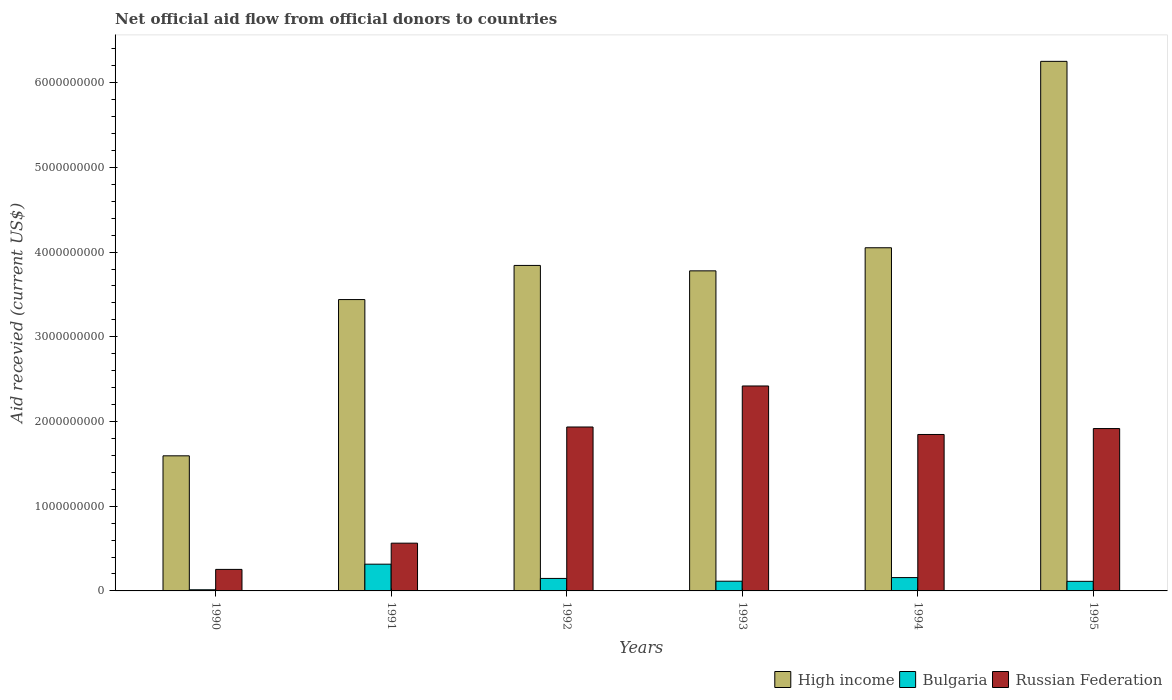How many different coloured bars are there?
Your answer should be very brief. 3. How many groups of bars are there?
Keep it short and to the point. 6. Are the number of bars per tick equal to the number of legend labels?
Make the answer very short. Yes. Are the number of bars on each tick of the X-axis equal?
Provide a short and direct response. Yes. What is the total aid received in Russian Federation in 1990?
Make the answer very short. 2.54e+08. Across all years, what is the maximum total aid received in Bulgaria?
Offer a terse response. 3.16e+08. Across all years, what is the minimum total aid received in Russian Federation?
Offer a terse response. 2.54e+08. In which year was the total aid received in High income minimum?
Keep it short and to the point. 1990. What is the total total aid received in High income in the graph?
Offer a terse response. 2.30e+1. What is the difference between the total aid received in Bulgaria in 1990 and that in 1993?
Keep it short and to the point. -1.01e+08. What is the difference between the total aid received in Bulgaria in 1993 and the total aid received in Russian Federation in 1990?
Provide a short and direct response. -1.39e+08. What is the average total aid received in Russian Federation per year?
Provide a succinct answer. 1.49e+09. In the year 1995, what is the difference between the total aid received in High income and total aid received in Bulgaria?
Give a very brief answer. 6.14e+09. In how many years, is the total aid received in High income greater than 1600000000 US$?
Make the answer very short. 5. What is the ratio of the total aid received in Bulgaria in 1992 to that in 1995?
Offer a very short reply. 1.3. What is the difference between the highest and the second highest total aid received in Bulgaria?
Your answer should be compact. 1.58e+08. What is the difference between the highest and the lowest total aid received in Russian Federation?
Provide a succinct answer. 2.17e+09. Is the sum of the total aid received in High income in 1990 and 1994 greater than the maximum total aid received in Russian Federation across all years?
Your answer should be compact. Yes. What does the 2nd bar from the right in 1995 represents?
Give a very brief answer. Bulgaria. Is it the case that in every year, the sum of the total aid received in High income and total aid received in Russian Federation is greater than the total aid received in Bulgaria?
Make the answer very short. Yes. Are all the bars in the graph horizontal?
Offer a very short reply. No. How many years are there in the graph?
Keep it short and to the point. 6. What is the difference between two consecutive major ticks on the Y-axis?
Your answer should be very brief. 1.00e+09. How many legend labels are there?
Keep it short and to the point. 3. How are the legend labels stacked?
Your answer should be compact. Horizontal. What is the title of the graph?
Provide a succinct answer. Net official aid flow from official donors to countries. What is the label or title of the Y-axis?
Provide a short and direct response. Aid recevied (current US$). What is the Aid recevied (current US$) in High income in 1990?
Your answer should be compact. 1.59e+09. What is the Aid recevied (current US$) in Bulgaria in 1990?
Provide a short and direct response. 1.36e+07. What is the Aid recevied (current US$) in Russian Federation in 1990?
Your answer should be compact. 2.54e+08. What is the Aid recevied (current US$) in High income in 1991?
Provide a succinct answer. 3.44e+09. What is the Aid recevied (current US$) of Bulgaria in 1991?
Your answer should be compact. 3.16e+08. What is the Aid recevied (current US$) in Russian Federation in 1991?
Keep it short and to the point. 5.64e+08. What is the Aid recevied (current US$) in High income in 1992?
Keep it short and to the point. 3.84e+09. What is the Aid recevied (current US$) in Bulgaria in 1992?
Ensure brevity in your answer.  1.48e+08. What is the Aid recevied (current US$) of Russian Federation in 1992?
Keep it short and to the point. 1.94e+09. What is the Aid recevied (current US$) of High income in 1993?
Provide a short and direct response. 3.78e+09. What is the Aid recevied (current US$) in Bulgaria in 1993?
Your response must be concise. 1.15e+08. What is the Aid recevied (current US$) in Russian Federation in 1993?
Offer a terse response. 2.42e+09. What is the Aid recevied (current US$) of High income in 1994?
Your answer should be compact. 4.05e+09. What is the Aid recevied (current US$) of Bulgaria in 1994?
Ensure brevity in your answer.  1.57e+08. What is the Aid recevied (current US$) in Russian Federation in 1994?
Your answer should be very brief. 1.85e+09. What is the Aid recevied (current US$) of High income in 1995?
Provide a succinct answer. 6.25e+09. What is the Aid recevied (current US$) in Bulgaria in 1995?
Make the answer very short. 1.13e+08. What is the Aid recevied (current US$) of Russian Federation in 1995?
Your response must be concise. 1.92e+09. Across all years, what is the maximum Aid recevied (current US$) of High income?
Ensure brevity in your answer.  6.25e+09. Across all years, what is the maximum Aid recevied (current US$) in Bulgaria?
Make the answer very short. 3.16e+08. Across all years, what is the maximum Aid recevied (current US$) of Russian Federation?
Provide a succinct answer. 2.42e+09. Across all years, what is the minimum Aid recevied (current US$) of High income?
Ensure brevity in your answer.  1.59e+09. Across all years, what is the minimum Aid recevied (current US$) of Bulgaria?
Make the answer very short. 1.36e+07. Across all years, what is the minimum Aid recevied (current US$) in Russian Federation?
Make the answer very short. 2.54e+08. What is the total Aid recevied (current US$) in High income in the graph?
Your response must be concise. 2.30e+1. What is the total Aid recevied (current US$) in Bulgaria in the graph?
Your response must be concise. 8.62e+08. What is the total Aid recevied (current US$) of Russian Federation in the graph?
Offer a very short reply. 8.94e+09. What is the difference between the Aid recevied (current US$) in High income in 1990 and that in 1991?
Your response must be concise. -1.84e+09. What is the difference between the Aid recevied (current US$) of Bulgaria in 1990 and that in 1991?
Ensure brevity in your answer.  -3.02e+08. What is the difference between the Aid recevied (current US$) in Russian Federation in 1990 and that in 1991?
Your answer should be compact. -3.10e+08. What is the difference between the Aid recevied (current US$) in High income in 1990 and that in 1992?
Ensure brevity in your answer.  -2.25e+09. What is the difference between the Aid recevied (current US$) of Bulgaria in 1990 and that in 1992?
Keep it short and to the point. -1.34e+08. What is the difference between the Aid recevied (current US$) of Russian Federation in 1990 and that in 1992?
Offer a terse response. -1.68e+09. What is the difference between the Aid recevied (current US$) of High income in 1990 and that in 1993?
Your answer should be compact. -2.18e+09. What is the difference between the Aid recevied (current US$) in Bulgaria in 1990 and that in 1993?
Make the answer very short. -1.01e+08. What is the difference between the Aid recevied (current US$) in Russian Federation in 1990 and that in 1993?
Offer a terse response. -2.17e+09. What is the difference between the Aid recevied (current US$) of High income in 1990 and that in 1994?
Offer a very short reply. -2.46e+09. What is the difference between the Aid recevied (current US$) of Bulgaria in 1990 and that in 1994?
Give a very brief answer. -1.44e+08. What is the difference between the Aid recevied (current US$) in Russian Federation in 1990 and that in 1994?
Offer a terse response. -1.59e+09. What is the difference between the Aid recevied (current US$) in High income in 1990 and that in 1995?
Keep it short and to the point. -4.66e+09. What is the difference between the Aid recevied (current US$) of Bulgaria in 1990 and that in 1995?
Your answer should be compact. -9.94e+07. What is the difference between the Aid recevied (current US$) in Russian Federation in 1990 and that in 1995?
Provide a short and direct response. -1.66e+09. What is the difference between the Aid recevied (current US$) in High income in 1991 and that in 1992?
Offer a very short reply. -4.03e+08. What is the difference between the Aid recevied (current US$) of Bulgaria in 1991 and that in 1992?
Ensure brevity in your answer.  1.68e+08. What is the difference between the Aid recevied (current US$) of Russian Federation in 1991 and that in 1992?
Your response must be concise. -1.37e+09. What is the difference between the Aid recevied (current US$) in High income in 1991 and that in 1993?
Give a very brief answer. -3.39e+08. What is the difference between the Aid recevied (current US$) in Bulgaria in 1991 and that in 1993?
Your answer should be very brief. 2.01e+08. What is the difference between the Aid recevied (current US$) of Russian Federation in 1991 and that in 1993?
Make the answer very short. -1.86e+09. What is the difference between the Aid recevied (current US$) of High income in 1991 and that in 1994?
Provide a succinct answer. -6.12e+08. What is the difference between the Aid recevied (current US$) in Bulgaria in 1991 and that in 1994?
Keep it short and to the point. 1.58e+08. What is the difference between the Aid recevied (current US$) in Russian Federation in 1991 and that in 1994?
Your answer should be very brief. -1.28e+09. What is the difference between the Aid recevied (current US$) in High income in 1991 and that in 1995?
Ensure brevity in your answer.  -2.81e+09. What is the difference between the Aid recevied (current US$) of Bulgaria in 1991 and that in 1995?
Keep it short and to the point. 2.03e+08. What is the difference between the Aid recevied (current US$) in Russian Federation in 1991 and that in 1995?
Offer a terse response. -1.35e+09. What is the difference between the Aid recevied (current US$) of High income in 1992 and that in 1993?
Your answer should be compact. 6.39e+07. What is the difference between the Aid recevied (current US$) in Bulgaria in 1992 and that in 1993?
Give a very brief answer. 3.29e+07. What is the difference between the Aid recevied (current US$) of Russian Federation in 1992 and that in 1993?
Offer a terse response. -4.84e+08. What is the difference between the Aid recevied (current US$) of High income in 1992 and that in 1994?
Provide a succinct answer. -2.09e+08. What is the difference between the Aid recevied (current US$) in Bulgaria in 1992 and that in 1994?
Provide a succinct answer. -9.83e+06. What is the difference between the Aid recevied (current US$) of Russian Federation in 1992 and that in 1994?
Ensure brevity in your answer.  8.82e+07. What is the difference between the Aid recevied (current US$) of High income in 1992 and that in 1995?
Offer a terse response. -2.41e+09. What is the difference between the Aid recevied (current US$) of Bulgaria in 1992 and that in 1995?
Your response must be concise. 3.44e+07. What is the difference between the Aid recevied (current US$) of Russian Federation in 1992 and that in 1995?
Give a very brief answer. 1.83e+07. What is the difference between the Aid recevied (current US$) of High income in 1993 and that in 1994?
Offer a terse response. -2.73e+08. What is the difference between the Aid recevied (current US$) in Bulgaria in 1993 and that in 1994?
Offer a terse response. -4.27e+07. What is the difference between the Aid recevied (current US$) in Russian Federation in 1993 and that in 1994?
Ensure brevity in your answer.  5.73e+08. What is the difference between the Aid recevied (current US$) of High income in 1993 and that in 1995?
Offer a very short reply. -2.47e+09. What is the difference between the Aid recevied (current US$) of Bulgaria in 1993 and that in 1995?
Offer a very short reply. 1.58e+06. What is the difference between the Aid recevied (current US$) in Russian Federation in 1993 and that in 1995?
Your response must be concise. 5.03e+08. What is the difference between the Aid recevied (current US$) of High income in 1994 and that in 1995?
Offer a terse response. -2.20e+09. What is the difference between the Aid recevied (current US$) in Bulgaria in 1994 and that in 1995?
Give a very brief answer. 4.43e+07. What is the difference between the Aid recevied (current US$) of Russian Federation in 1994 and that in 1995?
Keep it short and to the point. -6.99e+07. What is the difference between the Aid recevied (current US$) of High income in 1990 and the Aid recevied (current US$) of Bulgaria in 1991?
Provide a short and direct response. 1.28e+09. What is the difference between the Aid recevied (current US$) of High income in 1990 and the Aid recevied (current US$) of Russian Federation in 1991?
Provide a short and direct response. 1.03e+09. What is the difference between the Aid recevied (current US$) of Bulgaria in 1990 and the Aid recevied (current US$) of Russian Federation in 1991?
Provide a short and direct response. -5.50e+08. What is the difference between the Aid recevied (current US$) of High income in 1990 and the Aid recevied (current US$) of Bulgaria in 1992?
Provide a succinct answer. 1.45e+09. What is the difference between the Aid recevied (current US$) of High income in 1990 and the Aid recevied (current US$) of Russian Federation in 1992?
Offer a very short reply. -3.40e+08. What is the difference between the Aid recevied (current US$) of Bulgaria in 1990 and the Aid recevied (current US$) of Russian Federation in 1992?
Your answer should be compact. -1.92e+09. What is the difference between the Aid recevied (current US$) in High income in 1990 and the Aid recevied (current US$) in Bulgaria in 1993?
Provide a short and direct response. 1.48e+09. What is the difference between the Aid recevied (current US$) of High income in 1990 and the Aid recevied (current US$) of Russian Federation in 1993?
Keep it short and to the point. -8.25e+08. What is the difference between the Aid recevied (current US$) in Bulgaria in 1990 and the Aid recevied (current US$) in Russian Federation in 1993?
Provide a short and direct response. -2.41e+09. What is the difference between the Aid recevied (current US$) in High income in 1990 and the Aid recevied (current US$) in Bulgaria in 1994?
Make the answer very short. 1.44e+09. What is the difference between the Aid recevied (current US$) in High income in 1990 and the Aid recevied (current US$) in Russian Federation in 1994?
Ensure brevity in your answer.  -2.52e+08. What is the difference between the Aid recevied (current US$) in Bulgaria in 1990 and the Aid recevied (current US$) in Russian Federation in 1994?
Your answer should be very brief. -1.83e+09. What is the difference between the Aid recevied (current US$) in High income in 1990 and the Aid recevied (current US$) in Bulgaria in 1995?
Your response must be concise. 1.48e+09. What is the difference between the Aid recevied (current US$) in High income in 1990 and the Aid recevied (current US$) in Russian Federation in 1995?
Offer a terse response. -3.22e+08. What is the difference between the Aid recevied (current US$) of Bulgaria in 1990 and the Aid recevied (current US$) of Russian Federation in 1995?
Make the answer very short. -1.90e+09. What is the difference between the Aid recevied (current US$) in High income in 1991 and the Aid recevied (current US$) in Bulgaria in 1992?
Provide a short and direct response. 3.29e+09. What is the difference between the Aid recevied (current US$) in High income in 1991 and the Aid recevied (current US$) in Russian Federation in 1992?
Offer a very short reply. 1.50e+09. What is the difference between the Aid recevied (current US$) of Bulgaria in 1991 and the Aid recevied (current US$) of Russian Federation in 1992?
Your answer should be very brief. -1.62e+09. What is the difference between the Aid recevied (current US$) of High income in 1991 and the Aid recevied (current US$) of Bulgaria in 1993?
Offer a very short reply. 3.32e+09. What is the difference between the Aid recevied (current US$) in High income in 1991 and the Aid recevied (current US$) in Russian Federation in 1993?
Make the answer very short. 1.02e+09. What is the difference between the Aid recevied (current US$) in Bulgaria in 1991 and the Aid recevied (current US$) in Russian Federation in 1993?
Make the answer very short. -2.10e+09. What is the difference between the Aid recevied (current US$) in High income in 1991 and the Aid recevied (current US$) in Bulgaria in 1994?
Make the answer very short. 3.28e+09. What is the difference between the Aid recevied (current US$) in High income in 1991 and the Aid recevied (current US$) in Russian Federation in 1994?
Your answer should be compact. 1.59e+09. What is the difference between the Aid recevied (current US$) in Bulgaria in 1991 and the Aid recevied (current US$) in Russian Federation in 1994?
Ensure brevity in your answer.  -1.53e+09. What is the difference between the Aid recevied (current US$) in High income in 1991 and the Aid recevied (current US$) in Bulgaria in 1995?
Offer a terse response. 3.33e+09. What is the difference between the Aid recevied (current US$) of High income in 1991 and the Aid recevied (current US$) of Russian Federation in 1995?
Your answer should be compact. 1.52e+09. What is the difference between the Aid recevied (current US$) in Bulgaria in 1991 and the Aid recevied (current US$) in Russian Federation in 1995?
Your response must be concise. -1.60e+09. What is the difference between the Aid recevied (current US$) in High income in 1992 and the Aid recevied (current US$) in Bulgaria in 1993?
Keep it short and to the point. 3.73e+09. What is the difference between the Aid recevied (current US$) in High income in 1992 and the Aid recevied (current US$) in Russian Federation in 1993?
Your answer should be compact. 1.42e+09. What is the difference between the Aid recevied (current US$) in Bulgaria in 1992 and the Aid recevied (current US$) in Russian Federation in 1993?
Offer a very short reply. -2.27e+09. What is the difference between the Aid recevied (current US$) of High income in 1992 and the Aid recevied (current US$) of Bulgaria in 1994?
Keep it short and to the point. 3.68e+09. What is the difference between the Aid recevied (current US$) in High income in 1992 and the Aid recevied (current US$) in Russian Federation in 1994?
Provide a short and direct response. 2.00e+09. What is the difference between the Aid recevied (current US$) in Bulgaria in 1992 and the Aid recevied (current US$) in Russian Federation in 1994?
Provide a succinct answer. -1.70e+09. What is the difference between the Aid recevied (current US$) of High income in 1992 and the Aid recevied (current US$) of Bulgaria in 1995?
Provide a succinct answer. 3.73e+09. What is the difference between the Aid recevied (current US$) of High income in 1992 and the Aid recevied (current US$) of Russian Federation in 1995?
Provide a short and direct response. 1.93e+09. What is the difference between the Aid recevied (current US$) of Bulgaria in 1992 and the Aid recevied (current US$) of Russian Federation in 1995?
Your answer should be compact. -1.77e+09. What is the difference between the Aid recevied (current US$) of High income in 1993 and the Aid recevied (current US$) of Bulgaria in 1994?
Make the answer very short. 3.62e+09. What is the difference between the Aid recevied (current US$) of High income in 1993 and the Aid recevied (current US$) of Russian Federation in 1994?
Ensure brevity in your answer.  1.93e+09. What is the difference between the Aid recevied (current US$) in Bulgaria in 1993 and the Aid recevied (current US$) in Russian Federation in 1994?
Provide a short and direct response. -1.73e+09. What is the difference between the Aid recevied (current US$) in High income in 1993 and the Aid recevied (current US$) in Bulgaria in 1995?
Your answer should be very brief. 3.67e+09. What is the difference between the Aid recevied (current US$) of High income in 1993 and the Aid recevied (current US$) of Russian Federation in 1995?
Keep it short and to the point. 1.86e+09. What is the difference between the Aid recevied (current US$) of Bulgaria in 1993 and the Aid recevied (current US$) of Russian Federation in 1995?
Your answer should be very brief. -1.80e+09. What is the difference between the Aid recevied (current US$) of High income in 1994 and the Aid recevied (current US$) of Bulgaria in 1995?
Offer a terse response. 3.94e+09. What is the difference between the Aid recevied (current US$) of High income in 1994 and the Aid recevied (current US$) of Russian Federation in 1995?
Your answer should be very brief. 2.13e+09. What is the difference between the Aid recevied (current US$) in Bulgaria in 1994 and the Aid recevied (current US$) in Russian Federation in 1995?
Offer a very short reply. -1.76e+09. What is the average Aid recevied (current US$) of High income per year?
Give a very brief answer. 3.83e+09. What is the average Aid recevied (current US$) in Bulgaria per year?
Offer a very short reply. 1.44e+08. What is the average Aid recevied (current US$) in Russian Federation per year?
Provide a succinct answer. 1.49e+09. In the year 1990, what is the difference between the Aid recevied (current US$) of High income and Aid recevied (current US$) of Bulgaria?
Ensure brevity in your answer.  1.58e+09. In the year 1990, what is the difference between the Aid recevied (current US$) of High income and Aid recevied (current US$) of Russian Federation?
Your answer should be compact. 1.34e+09. In the year 1990, what is the difference between the Aid recevied (current US$) in Bulgaria and Aid recevied (current US$) in Russian Federation?
Keep it short and to the point. -2.40e+08. In the year 1991, what is the difference between the Aid recevied (current US$) in High income and Aid recevied (current US$) in Bulgaria?
Provide a succinct answer. 3.12e+09. In the year 1991, what is the difference between the Aid recevied (current US$) in High income and Aid recevied (current US$) in Russian Federation?
Your answer should be compact. 2.88e+09. In the year 1991, what is the difference between the Aid recevied (current US$) in Bulgaria and Aid recevied (current US$) in Russian Federation?
Your answer should be compact. -2.48e+08. In the year 1992, what is the difference between the Aid recevied (current US$) in High income and Aid recevied (current US$) in Bulgaria?
Your answer should be very brief. 3.69e+09. In the year 1992, what is the difference between the Aid recevied (current US$) in High income and Aid recevied (current US$) in Russian Federation?
Offer a terse response. 1.91e+09. In the year 1992, what is the difference between the Aid recevied (current US$) in Bulgaria and Aid recevied (current US$) in Russian Federation?
Your answer should be compact. -1.79e+09. In the year 1993, what is the difference between the Aid recevied (current US$) of High income and Aid recevied (current US$) of Bulgaria?
Keep it short and to the point. 3.66e+09. In the year 1993, what is the difference between the Aid recevied (current US$) of High income and Aid recevied (current US$) of Russian Federation?
Make the answer very short. 1.36e+09. In the year 1993, what is the difference between the Aid recevied (current US$) of Bulgaria and Aid recevied (current US$) of Russian Federation?
Offer a terse response. -2.30e+09. In the year 1994, what is the difference between the Aid recevied (current US$) of High income and Aid recevied (current US$) of Bulgaria?
Give a very brief answer. 3.89e+09. In the year 1994, what is the difference between the Aid recevied (current US$) of High income and Aid recevied (current US$) of Russian Federation?
Provide a short and direct response. 2.20e+09. In the year 1994, what is the difference between the Aid recevied (current US$) in Bulgaria and Aid recevied (current US$) in Russian Federation?
Provide a short and direct response. -1.69e+09. In the year 1995, what is the difference between the Aid recevied (current US$) of High income and Aid recevied (current US$) of Bulgaria?
Your response must be concise. 6.14e+09. In the year 1995, what is the difference between the Aid recevied (current US$) of High income and Aid recevied (current US$) of Russian Federation?
Give a very brief answer. 4.33e+09. In the year 1995, what is the difference between the Aid recevied (current US$) in Bulgaria and Aid recevied (current US$) in Russian Federation?
Your answer should be compact. -1.80e+09. What is the ratio of the Aid recevied (current US$) of High income in 1990 to that in 1991?
Keep it short and to the point. 0.46. What is the ratio of the Aid recevied (current US$) in Bulgaria in 1990 to that in 1991?
Make the answer very short. 0.04. What is the ratio of the Aid recevied (current US$) of Russian Federation in 1990 to that in 1991?
Your response must be concise. 0.45. What is the ratio of the Aid recevied (current US$) in High income in 1990 to that in 1992?
Give a very brief answer. 0.42. What is the ratio of the Aid recevied (current US$) of Bulgaria in 1990 to that in 1992?
Offer a terse response. 0.09. What is the ratio of the Aid recevied (current US$) of Russian Federation in 1990 to that in 1992?
Your answer should be very brief. 0.13. What is the ratio of the Aid recevied (current US$) of High income in 1990 to that in 1993?
Provide a short and direct response. 0.42. What is the ratio of the Aid recevied (current US$) of Bulgaria in 1990 to that in 1993?
Provide a short and direct response. 0.12. What is the ratio of the Aid recevied (current US$) of Russian Federation in 1990 to that in 1993?
Keep it short and to the point. 0.1. What is the ratio of the Aid recevied (current US$) in High income in 1990 to that in 1994?
Provide a short and direct response. 0.39. What is the ratio of the Aid recevied (current US$) of Bulgaria in 1990 to that in 1994?
Your answer should be compact. 0.09. What is the ratio of the Aid recevied (current US$) in Russian Federation in 1990 to that in 1994?
Give a very brief answer. 0.14. What is the ratio of the Aid recevied (current US$) of High income in 1990 to that in 1995?
Keep it short and to the point. 0.26. What is the ratio of the Aid recevied (current US$) of Bulgaria in 1990 to that in 1995?
Your answer should be compact. 0.12. What is the ratio of the Aid recevied (current US$) in Russian Federation in 1990 to that in 1995?
Make the answer very short. 0.13. What is the ratio of the Aid recevied (current US$) in High income in 1991 to that in 1992?
Your response must be concise. 0.9. What is the ratio of the Aid recevied (current US$) of Bulgaria in 1991 to that in 1992?
Provide a short and direct response. 2.14. What is the ratio of the Aid recevied (current US$) of Russian Federation in 1991 to that in 1992?
Offer a very short reply. 0.29. What is the ratio of the Aid recevied (current US$) of High income in 1991 to that in 1993?
Make the answer very short. 0.91. What is the ratio of the Aid recevied (current US$) in Bulgaria in 1991 to that in 1993?
Your answer should be very brief. 2.75. What is the ratio of the Aid recevied (current US$) of Russian Federation in 1991 to that in 1993?
Your answer should be very brief. 0.23. What is the ratio of the Aid recevied (current US$) in High income in 1991 to that in 1994?
Offer a terse response. 0.85. What is the ratio of the Aid recevied (current US$) in Bulgaria in 1991 to that in 1994?
Offer a terse response. 2.01. What is the ratio of the Aid recevied (current US$) in Russian Federation in 1991 to that in 1994?
Keep it short and to the point. 0.31. What is the ratio of the Aid recevied (current US$) of High income in 1991 to that in 1995?
Your answer should be compact. 0.55. What is the ratio of the Aid recevied (current US$) in Bulgaria in 1991 to that in 1995?
Offer a very short reply. 2.79. What is the ratio of the Aid recevied (current US$) in Russian Federation in 1991 to that in 1995?
Offer a very short reply. 0.29. What is the ratio of the Aid recevied (current US$) in High income in 1992 to that in 1993?
Your answer should be very brief. 1.02. What is the ratio of the Aid recevied (current US$) of Bulgaria in 1992 to that in 1993?
Your response must be concise. 1.29. What is the ratio of the Aid recevied (current US$) in Russian Federation in 1992 to that in 1993?
Offer a very short reply. 0.8. What is the ratio of the Aid recevied (current US$) in High income in 1992 to that in 1994?
Provide a succinct answer. 0.95. What is the ratio of the Aid recevied (current US$) of Russian Federation in 1992 to that in 1994?
Your answer should be very brief. 1.05. What is the ratio of the Aid recevied (current US$) in High income in 1992 to that in 1995?
Your answer should be compact. 0.61. What is the ratio of the Aid recevied (current US$) in Bulgaria in 1992 to that in 1995?
Your response must be concise. 1.3. What is the ratio of the Aid recevied (current US$) of Russian Federation in 1992 to that in 1995?
Your answer should be compact. 1.01. What is the ratio of the Aid recevied (current US$) of High income in 1993 to that in 1994?
Give a very brief answer. 0.93. What is the ratio of the Aid recevied (current US$) in Bulgaria in 1993 to that in 1994?
Offer a very short reply. 0.73. What is the ratio of the Aid recevied (current US$) in Russian Federation in 1993 to that in 1994?
Offer a very short reply. 1.31. What is the ratio of the Aid recevied (current US$) of High income in 1993 to that in 1995?
Your answer should be very brief. 0.6. What is the ratio of the Aid recevied (current US$) in Russian Federation in 1993 to that in 1995?
Give a very brief answer. 1.26. What is the ratio of the Aid recevied (current US$) in High income in 1994 to that in 1995?
Your response must be concise. 0.65. What is the ratio of the Aid recevied (current US$) in Bulgaria in 1994 to that in 1995?
Provide a short and direct response. 1.39. What is the ratio of the Aid recevied (current US$) of Russian Federation in 1994 to that in 1995?
Make the answer very short. 0.96. What is the difference between the highest and the second highest Aid recevied (current US$) in High income?
Offer a very short reply. 2.20e+09. What is the difference between the highest and the second highest Aid recevied (current US$) of Bulgaria?
Your answer should be very brief. 1.58e+08. What is the difference between the highest and the second highest Aid recevied (current US$) in Russian Federation?
Your answer should be compact. 4.84e+08. What is the difference between the highest and the lowest Aid recevied (current US$) of High income?
Keep it short and to the point. 4.66e+09. What is the difference between the highest and the lowest Aid recevied (current US$) of Bulgaria?
Your answer should be compact. 3.02e+08. What is the difference between the highest and the lowest Aid recevied (current US$) in Russian Federation?
Your answer should be compact. 2.17e+09. 